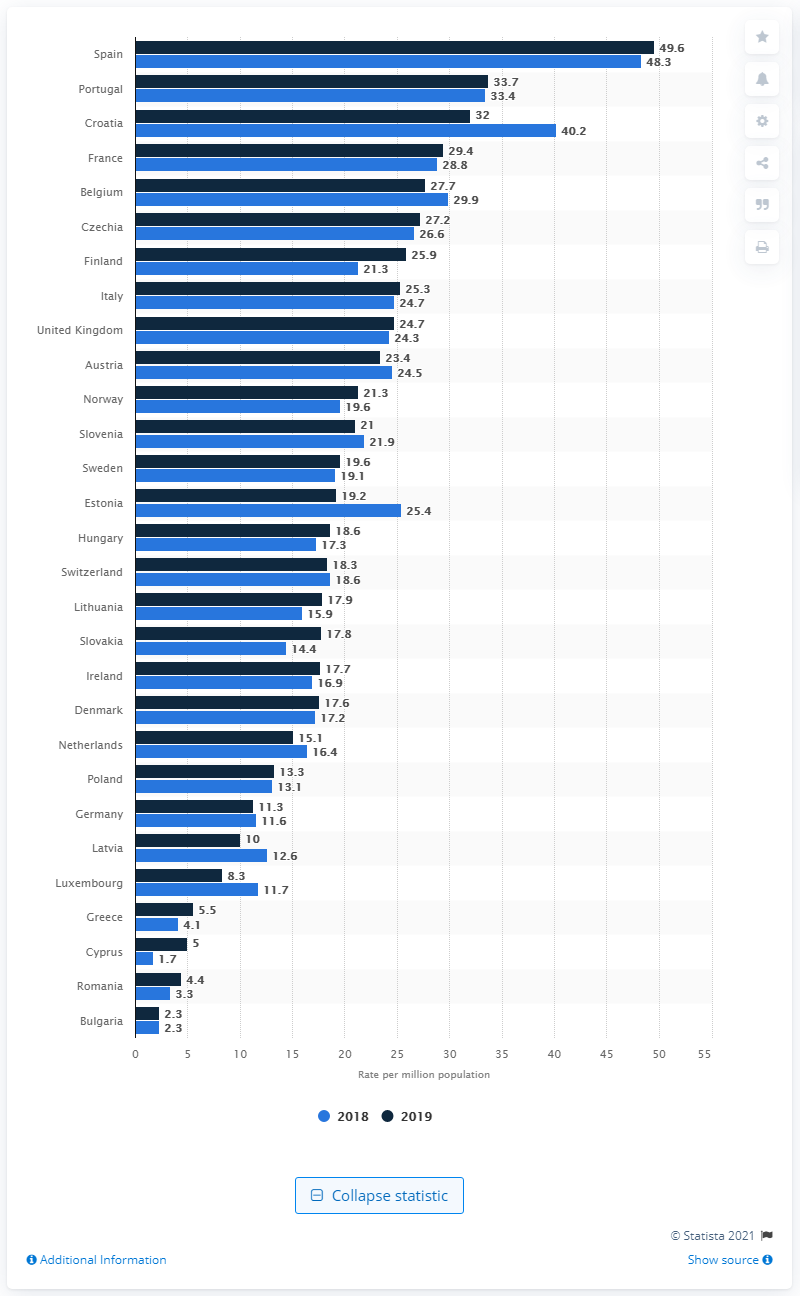Indicate a few pertinent items in this graphic. According to the data, Finland had the largest increase in the rate of organ donation between 2018 and 2019 compared to other countries. Portugal had the second highest rate of deceased organ donation in Europe. Spain had the highest rate of deceased donors in Europe in 2019. In 2019, the rate of organ donation in Spain was 49.6 donors per million population. 